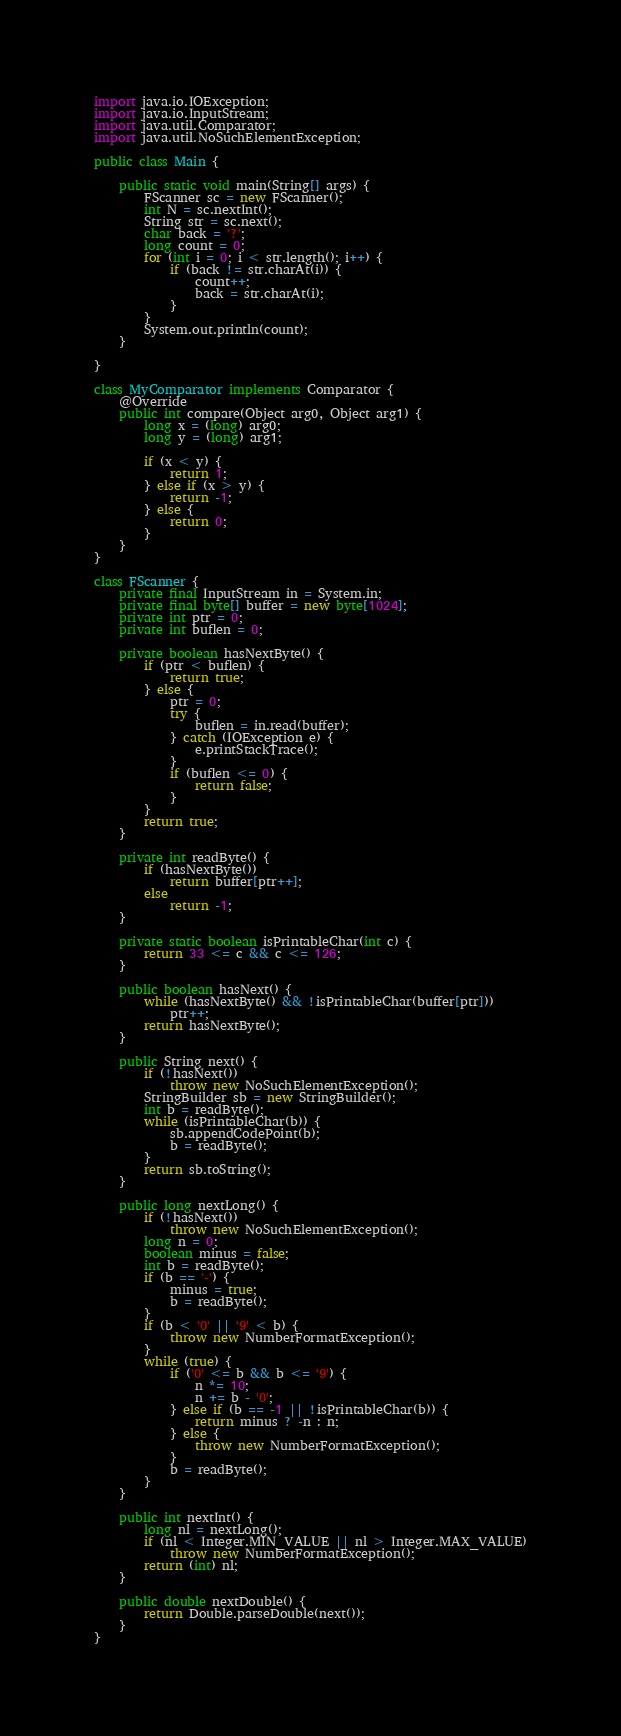Convert code to text. <code><loc_0><loc_0><loc_500><loc_500><_Java_>import java.io.IOException;
import java.io.InputStream;
import java.util.Comparator;
import java.util.NoSuchElementException;

public class Main {

	public static void main(String[] args) {
		FScanner sc = new FScanner();
		int N = sc.nextInt();
		String str = sc.next();
		char back = '?';
		long count = 0;
		for (int i = 0; i < str.length(); i++) {
			if (back != str.charAt(i)) {
				count++;
				back = str.charAt(i);
			}
		}
		System.out.println(count);
	}

}

class MyComparator implements Comparator {
	@Override
	public int compare(Object arg0, Object arg1) {
		long x = (long) arg0;
		long y = (long) arg1;

		if (x < y) {
			return 1;
		} else if (x > y) {
			return -1;
		} else {
			return 0;
		}
	}
}

class FScanner {
	private final InputStream in = System.in;
	private final byte[] buffer = new byte[1024];
	private int ptr = 0;
	private int buflen = 0;

	private boolean hasNextByte() {
		if (ptr < buflen) {
			return true;
		} else {
			ptr = 0;
			try {
				buflen = in.read(buffer);
			} catch (IOException e) {
				e.printStackTrace();
			}
			if (buflen <= 0) {
				return false;
			}
		}
		return true;
	}

	private int readByte() {
		if (hasNextByte())
			return buffer[ptr++];
		else
			return -1;
	}

	private static boolean isPrintableChar(int c) {
		return 33 <= c && c <= 126;
	}

	public boolean hasNext() {
		while (hasNextByte() && !isPrintableChar(buffer[ptr]))
			ptr++;
		return hasNextByte();
	}

	public String next() {
		if (!hasNext())
			throw new NoSuchElementException();
		StringBuilder sb = new StringBuilder();
		int b = readByte();
		while (isPrintableChar(b)) {
			sb.appendCodePoint(b);
			b = readByte();
		}
		return sb.toString();
	}

	public long nextLong() {
		if (!hasNext())
			throw new NoSuchElementException();
		long n = 0;
		boolean minus = false;
		int b = readByte();
		if (b == '-') {
			minus = true;
			b = readByte();
		}
		if (b < '0' || '9' < b) {
			throw new NumberFormatException();
		}
		while (true) {
			if ('0' <= b && b <= '9') {
				n *= 10;
				n += b - '0';
			} else if (b == -1 || !isPrintableChar(b)) {
				return minus ? -n : n;
			} else {
				throw new NumberFormatException();
			}
			b = readByte();
		}
	}

	public int nextInt() {
		long nl = nextLong();
		if (nl < Integer.MIN_VALUE || nl > Integer.MAX_VALUE)
			throw new NumberFormatException();
		return (int) nl;
	}

	public double nextDouble() {
		return Double.parseDouble(next());
	}
}</code> 